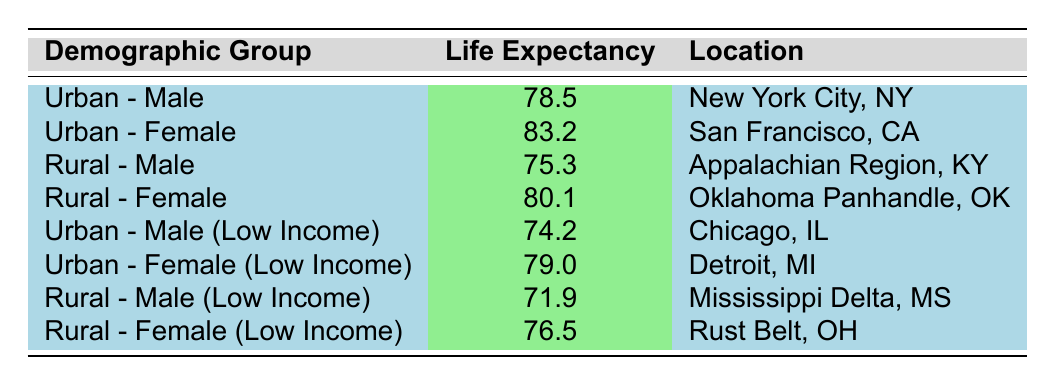What is the average life expectancy for Urban - Males? The table shows that the life expectancy for Urban - Males is 78.5 years.
Answer: 78.5 What is the life expectancy for Rural - Female in the Oklahoma Panhandle? According to the table, the life expectancy for Rural - Female in the Oklahoma Panhandle is 80.1 years.
Answer: 80.1 Is the average life expectancy for Rural - Males greater than for Urban - Males? The life expectancy for Rural - Males is 75.3 years, and for Urban - Males, it is 78.5 years. Since 75.3 is less than 78.5, the answer is no.
Answer: No What is the life expectancy for Urban - Female (Low Income)? The table indicates that the life expectancy for Urban - Female (Low Income) is 79.0 years.
Answer: 79.0 What is the difference in life expectancy between Urban - Male and Rural - Male? The life expectancy for Urban - Male is 78.5 years and for Rural - Male, it is 75.3 years. Subtracting these values gives 78.5 - 75.3 = 3.2 years.
Answer: 3.2 years What is the average life expectancy for Rural - Female (Low Income) and Rural - Female? The average for Rural - Female (Low Income) is 76.5 years and for Rural - Female is 80.1 years. Adding these gives 76.5 + 80.1 = 156.6 years. To find the average, divide by 2: 156.6 / 2 = 78.3 years.
Answer: 78.3 Is there a higher life expectancy for Urban - Females compared to Urban - Females (Low Income)? The life expectancy for Urban - Females is 83.2 years and for Urban - Females (Low Income), it is 79.0 years. Since 83.2 is higher than 79.0, the answer is yes.
Answer: Yes Which demographic group has the lowest average life expectancy? Reviewing the table, the lowest is Rural - Male (Low Income) with an average life expectancy of 71.9 years.
Answer: Rural - Male (Low Income) 